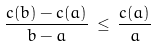<formula> <loc_0><loc_0><loc_500><loc_500>\frac { c ( b ) - c ( a ) } { b - a } \, \leq \, \frac { c ( a ) } { a }</formula> 